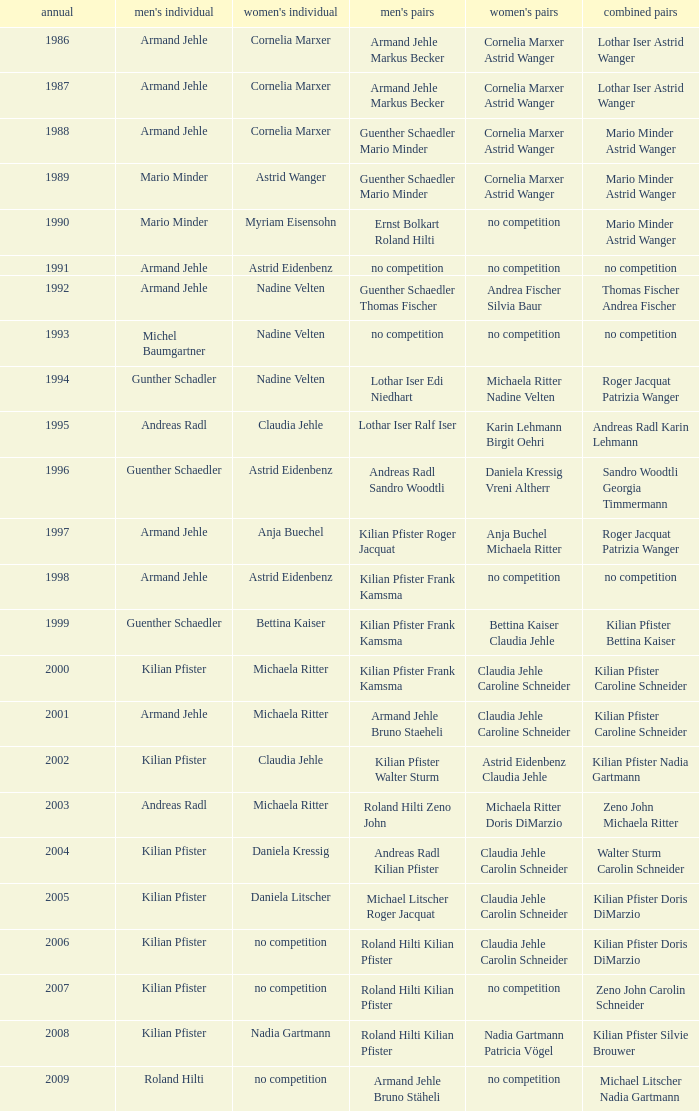In 2001, where the mens singles is armand jehle and the womens singles is michaela ritter, who are the mixed doubles Kilian Pfister Caroline Schneider. 